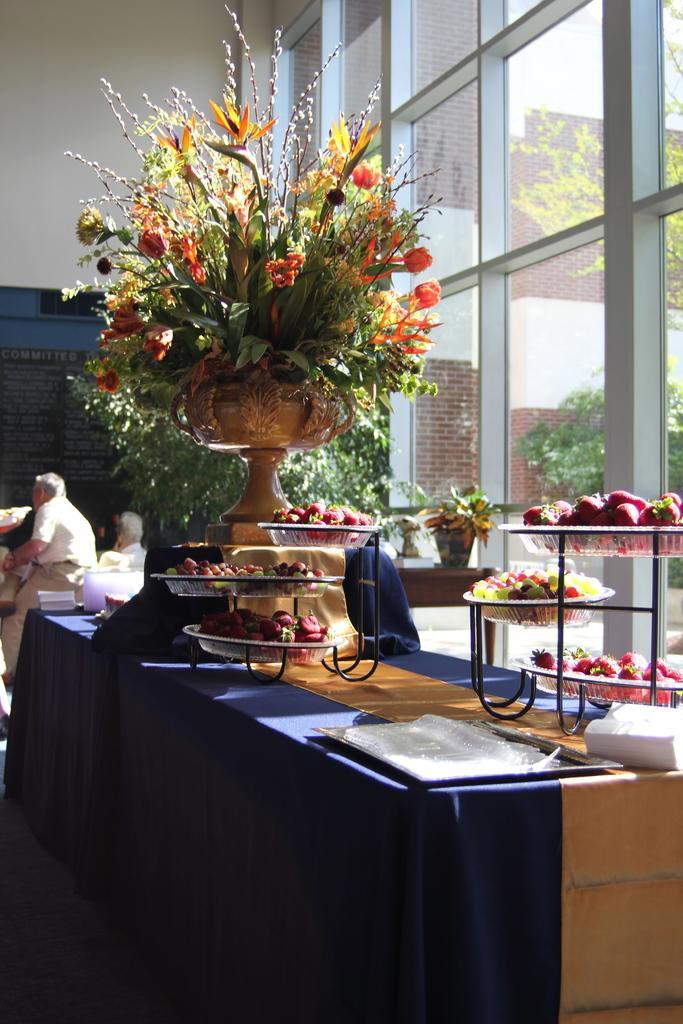In one or two sentences, can you explain what this image depicts? In this picture there is beautiful flower vase kept on top of a table, and a few baskets filled with fruits are on top of the table. In the background we observe many glass windows mounted to the wall and also few people sitting on the left side of the image. 